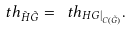Convert formula to latex. <formula><loc_0><loc_0><loc_500><loc_500>\ t h _ { \tilde { H } \tilde { G } } = \ t h _ { H G | _ { C ( \tilde { G } ) } } .</formula> 